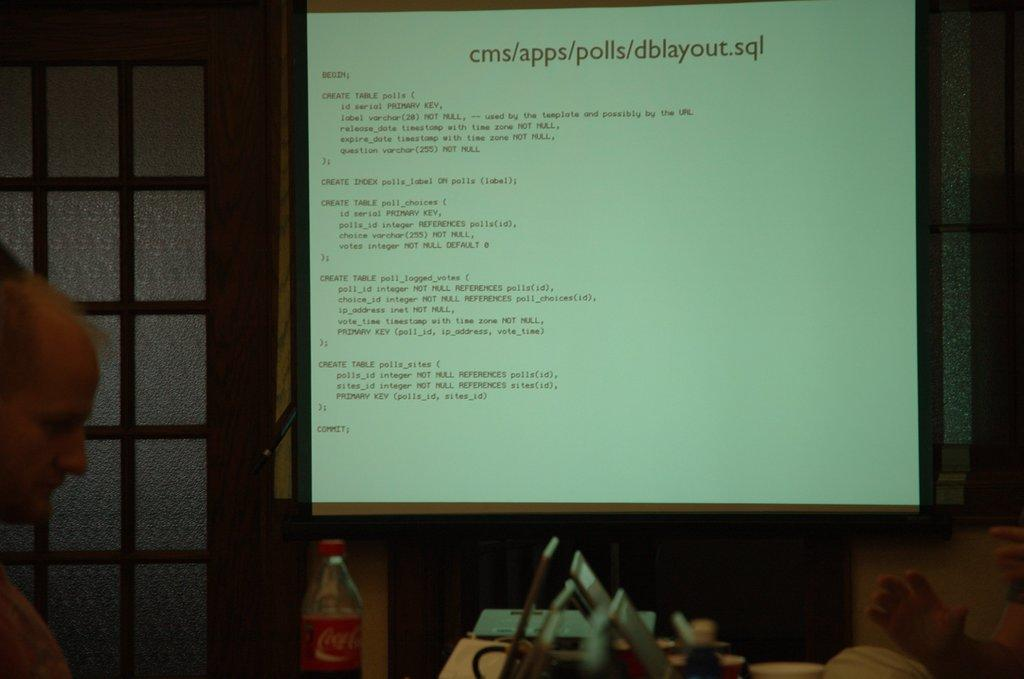<image>
Describe the image concisely. a large computer screen with the word Begin on it 